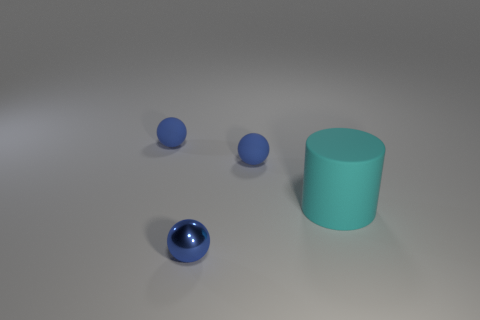There is a blue metallic sphere that is in front of the matte ball that is to the left of the metal sphere; are there any tiny blue rubber things that are behind it? After reviewing the image, there are no small blue rubber objects present behind the blue metallic sphere. The scene includes only three blue spheres of different textures and a matte green cylinder. All objects appear to be in plain view without smaller items hidden behind them. 